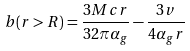Convert formula to latex. <formula><loc_0><loc_0><loc_500><loc_500>b ( r > R ) = \frac { 3 M c r } { 3 2 \pi \alpha _ { g } } - \frac { 3 v } { 4 \alpha _ { g } r }</formula> 